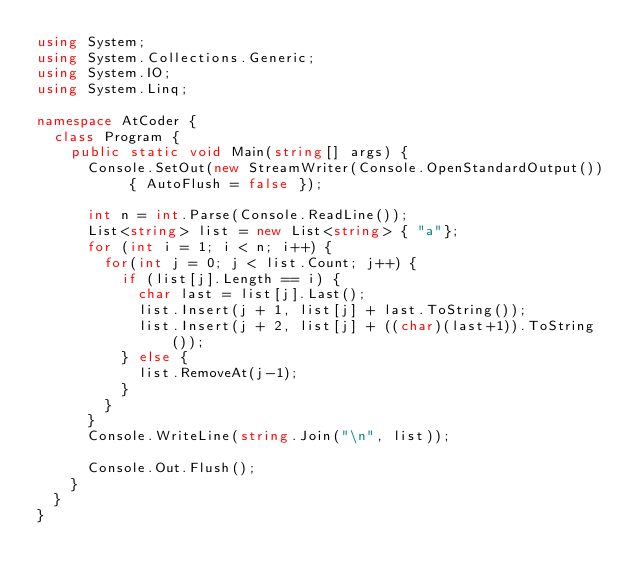Convert code to text. <code><loc_0><loc_0><loc_500><loc_500><_C#_>using System;
using System.Collections.Generic;
using System.IO;
using System.Linq;

namespace AtCoder {
	class Program {
		public static void Main(string[] args) {
			Console.SetOut(new StreamWriter(Console.OpenStandardOutput()) { AutoFlush = false });
			
			int n = int.Parse(Console.ReadLine());
			List<string> list = new List<string> { "a"};
			for (int i = 1; i < n; i++) {
				for(int j = 0; j < list.Count; j++) {
					if (list[j].Length == i) {
						char last = list[j].Last();
						list.Insert(j + 1, list[j] + last.ToString());
						list.Insert(j + 2, list[j] + ((char)(last+1)).ToString());
					} else {
						list.RemoveAt(j-1);
					}
				}
			}
			Console.WriteLine(string.Join("\n", list));

			Console.Out.Flush();
		}
	}
}
</code> 